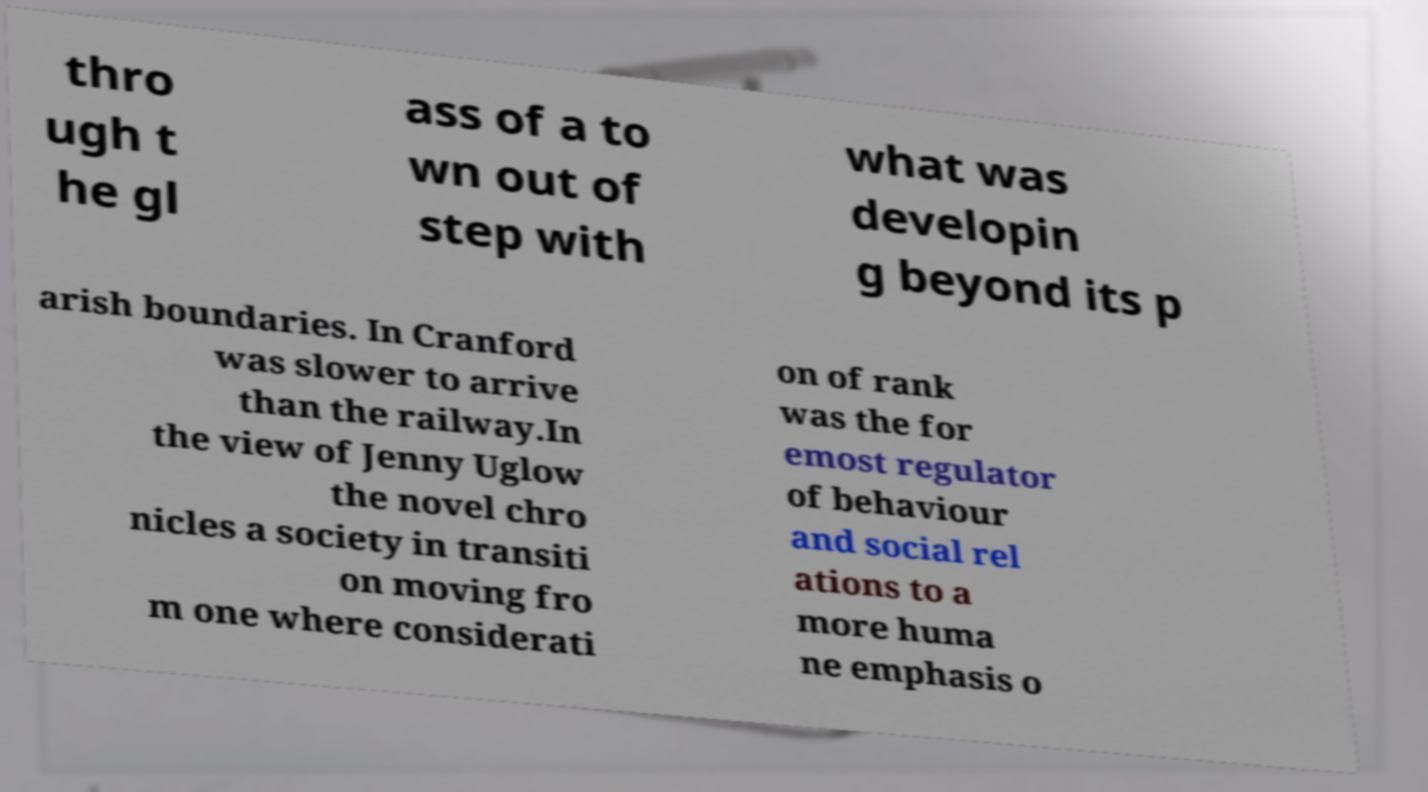I need the written content from this picture converted into text. Can you do that? thro ugh t he gl ass of a to wn out of step with what was developin g beyond its p arish boundaries. In Cranford was slower to arrive than the railway.In the view of Jenny Uglow the novel chro nicles a society in transiti on moving fro m one where considerati on of rank was the for emost regulator of behaviour and social rel ations to a more huma ne emphasis o 